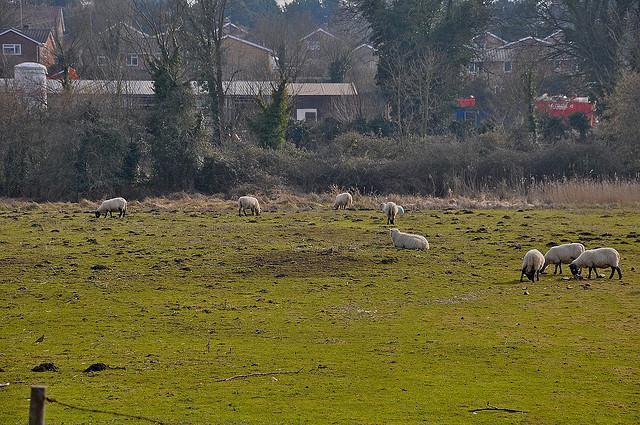How many sheep are in the pasture?
Give a very brief answer. 8. How many sheep are in the back?
Give a very brief answer. 8. How many sheep are there?
Give a very brief answer. 8. How many people are on top of elephants?
Give a very brief answer. 0. 